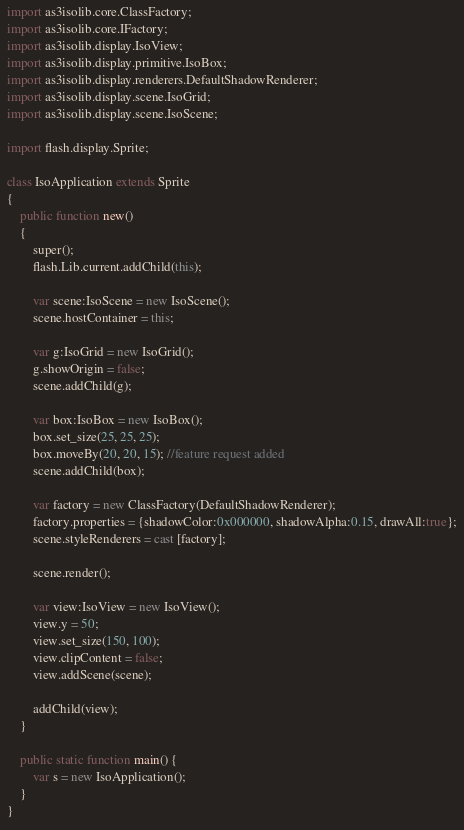Convert code to text. <code><loc_0><loc_0><loc_500><loc_500><_Haxe_>import as3isolib.core.ClassFactory;
import as3isolib.core.IFactory;
import as3isolib.display.IsoView;
import as3isolib.display.primitive.IsoBox;
import as3isolib.display.renderers.DefaultShadowRenderer;
import as3isolib.display.scene.IsoGrid;
import as3isolib.display.scene.IsoScene;

import flash.display.Sprite;

class IsoApplication extends Sprite
{
	public function new()
	{             
		super();
		flash.Lib.current.addChild(this);
          
		var scene:IsoScene = new IsoScene();
		scene.hostContainer = this;
		
		var g:IsoGrid = new IsoGrid();
		g.showOrigin = false;
		scene.addChild(g);
		
		var box:IsoBox = new IsoBox();
		box.set_size(25, 25, 25);
		box.moveBy(20, 20, 15); //feature request added
		scene.addChild(box);
		
		var factory = new ClassFactory(DefaultShadowRenderer);
		factory.properties = {shadowColor:0x000000, shadowAlpha:0.15, drawAll:true};
		scene.styleRenderers = cast [factory];
		
		scene.render();
		
		var view:IsoView = new IsoView();
		view.y = 50;
		view.set_size(150, 100);
		view.clipContent = false;
		view.addScene(scene);
		
		addChild(view);
	}

	public static function main() {
		var s = new IsoApplication();
	}
}
</code> 